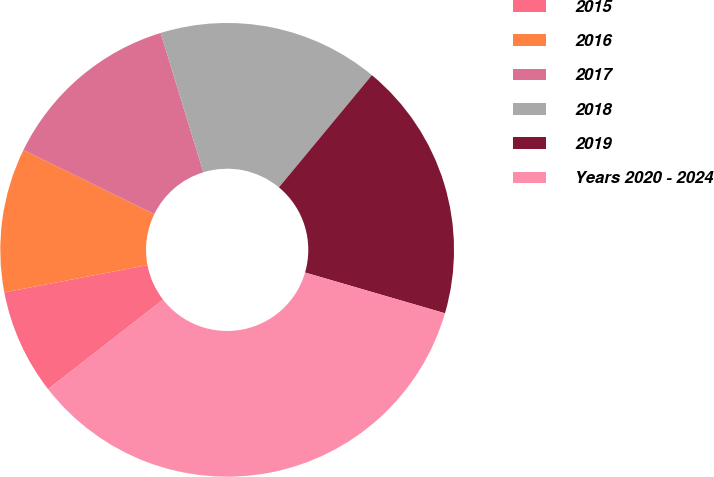Convert chart. <chart><loc_0><loc_0><loc_500><loc_500><pie_chart><fcel>2015<fcel>2016<fcel>2017<fcel>2018<fcel>2019<fcel>Years 2020 - 2024<nl><fcel>7.52%<fcel>10.26%<fcel>13.01%<fcel>15.75%<fcel>18.5%<fcel>34.97%<nl></chart> 